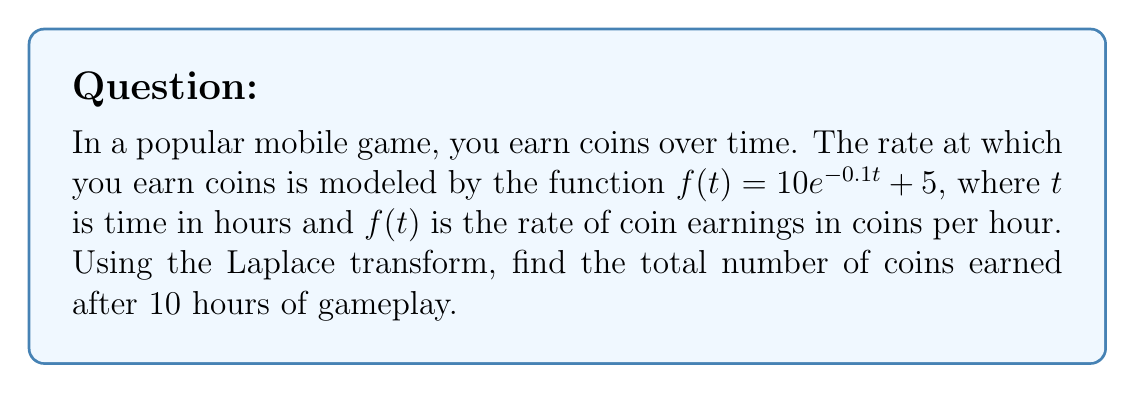Provide a solution to this math problem. Let's approach this step-by-step:

1) First, we need to find the Laplace transform of $f(t)$:

   $\mathcal{L}\{f(t)\} = \mathcal{L}\{10e^{-0.1t} + 5\}$

2) Using linearity property and the Laplace transform of exponential function:

   $\mathcal{L}\{f(t)\} = 10\mathcal{L}\{e^{-0.1t}\} + 5\mathcal{L}\{1\}$
   
   $= \frac{10}{s+0.1} + \frac{5}{s}$

3) To find the total number of coins, we need to integrate $f(t)$ from 0 to 10. In the Laplace domain, this is equivalent to multiplying by $\frac{1}{s}$ and then finding the inverse Laplace transform:

   $F(s) = \frac{1}{s}(\frac{10}{s+0.1} + \frac{5}{s}) = \frac{10}{s(s+0.1)} + \frac{5}{s^2}$

4) Now, we need to find the inverse Laplace transform of $F(s)$:

   $\mathcal{L}^{-1}\{F(s)\} = \mathcal{L}^{-1}\{\frac{10}{s(s+0.1)} + \frac{5}{s^2}\}$

5) Using partial fraction decomposition for the first term:

   $\frac{10}{s(s+0.1)} = \frac{100}{s} - \frac{100}{s+0.1}$

6) Now we can easily find the inverse Laplace transform:

   $\mathcal{L}^{-1}\{F(s)\} = 100 - 100e^{-0.1t} + 5t$

7) This gives us the function for the total number of coins at time $t$. To find the number of coins after 10 hours, we substitute $t=10$:

   $\text{Total coins} = 100 - 100e^{-0.1(10)} + 5(10)$
                       $= 100 - 100e^{-1} + 50$
                       $\approx 136.79$
Answer: After 10 hours of gameplay, approximately 136.79 coins will be earned. 